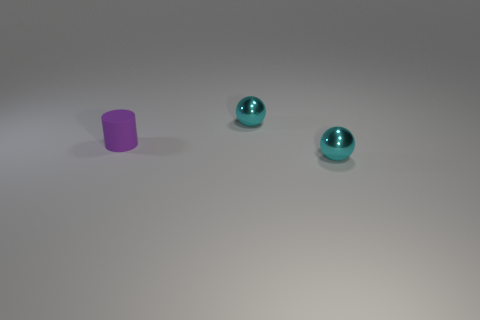Is the color of the ball that is in front of the small purple rubber cylinder the same as the small cylinder?
Offer a terse response. No. How many purple objects have the same material as the tiny purple cylinder?
Provide a short and direct response. 0. How many tiny cyan spheres are on the left side of the purple matte object?
Offer a terse response. 0. What is the size of the purple cylinder?
Offer a very short reply. Small. Are there any other tiny objects of the same color as the small rubber thing?
Offer a terse response. No. What material is the small purple thing?
Your answer should be compact. Rubber. What number of metal objects are there?
Your answer should be compact. 2. There is a object in front of the small purple matte thing; is its color the same as the small metal sphere that is behind the small purple matte cylinder?
Offer a very short reply. Yes. What number of other objects are there of the same size as the cylinder?
Your answer should be compact. 2. The small object behind the purple matte object is what color?
Provide a short and direct response. Cyan. 